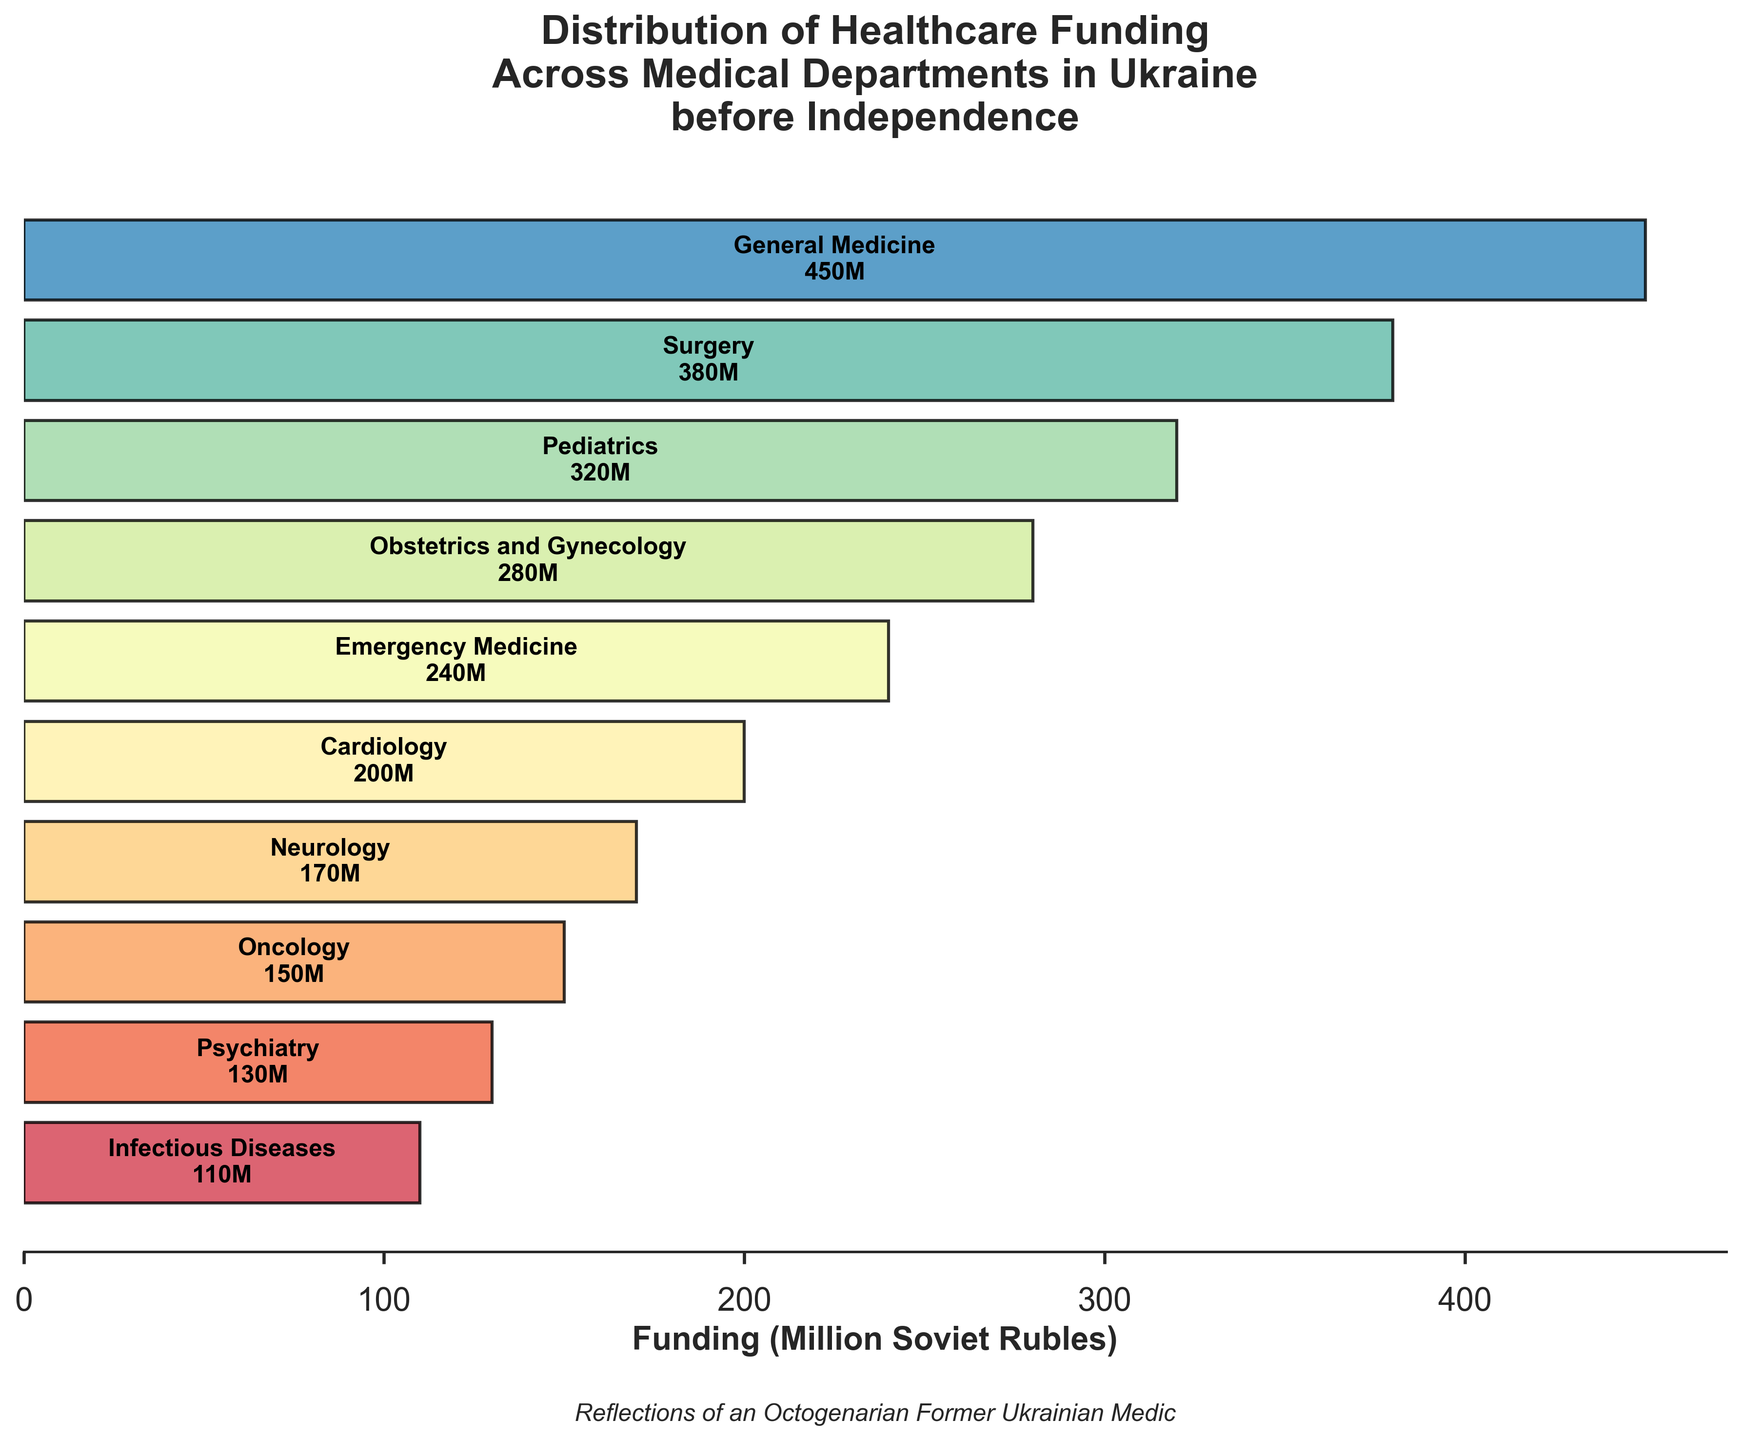What is the title of the figure? The title is usually located at the top of the figure. By directly reading the top, we can see that the title is "Distribution of Healthcare Funding Across Medical Departments in Ukraine before Independence".
Answer: Distribution of Healthcare Funding Across Medical Departments in Ukraine before Independence Which medical department received the highest funding? To find out which department received the highest funding, look at the widest bar at the top of the funnel. The department at the top with the widest bar is "General Medicine" with 450 million Soviet Rubles.
Answer: General Medicine How much funding did Neurology receive? Locate the Neurology department in the figure and read the text inside or next to its bar. The amount specified for Neurology is 170 million Soviet Rubles.
Answer: 170 million Soviet Rubles Compare the funding for Pediatrics and Cardiology. Which one received more, and by how much? Look at the bar for Pediatrics and Cardiology and note their funding amounts. Pediatrics received 320 million Soviet Rubles and Cardiology received 200 million Soviet Rubles. The difference is 320 - 200 = 120 million Soviet Rubles.
Answer: Pediatrics received 120 million Soviet Rubles more than Cardiology What is the combined funding for the three departments with the lowest funding? Identify the three departments with the least funding and sum their funding amounts. The three departments are Infectious Diseases (110), Psychiatry (130), and Oncology (150). The combined funding is 110 + 130 + 150 = 390 million Soviet Rubles.
Answer: 390 million Soviet Rubles Which department is placed in the middle in terms of funding, and how much did it receive? In the ordered list, the middle department (5th out of 10) can be found by locating the 5th department from either end. Emergency Medicine is the middle department with 240 million Soviet Rubles.
Answer: Emergency Medicine with 240 million Soviet Rubles Which two departments received the same amount of funding, if any? Scan through the figure to see if any two bars have the same length and corresponding funding values. In the chart provided, no two departments received the exact same amount of funding.
Answer: None 